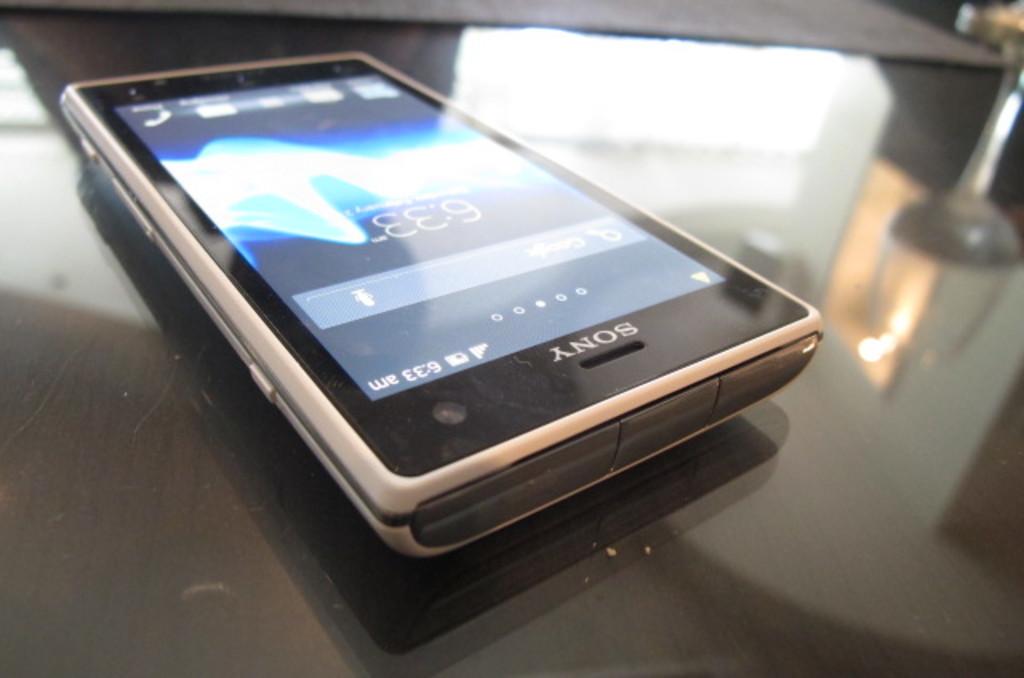What time does the phone say?
Your answer should be compact. 6:33. 